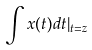<formula> <loc_0><loc_0><loc_500><loc_500>\int x ( t ) d t | _ { t = z }</formula> 